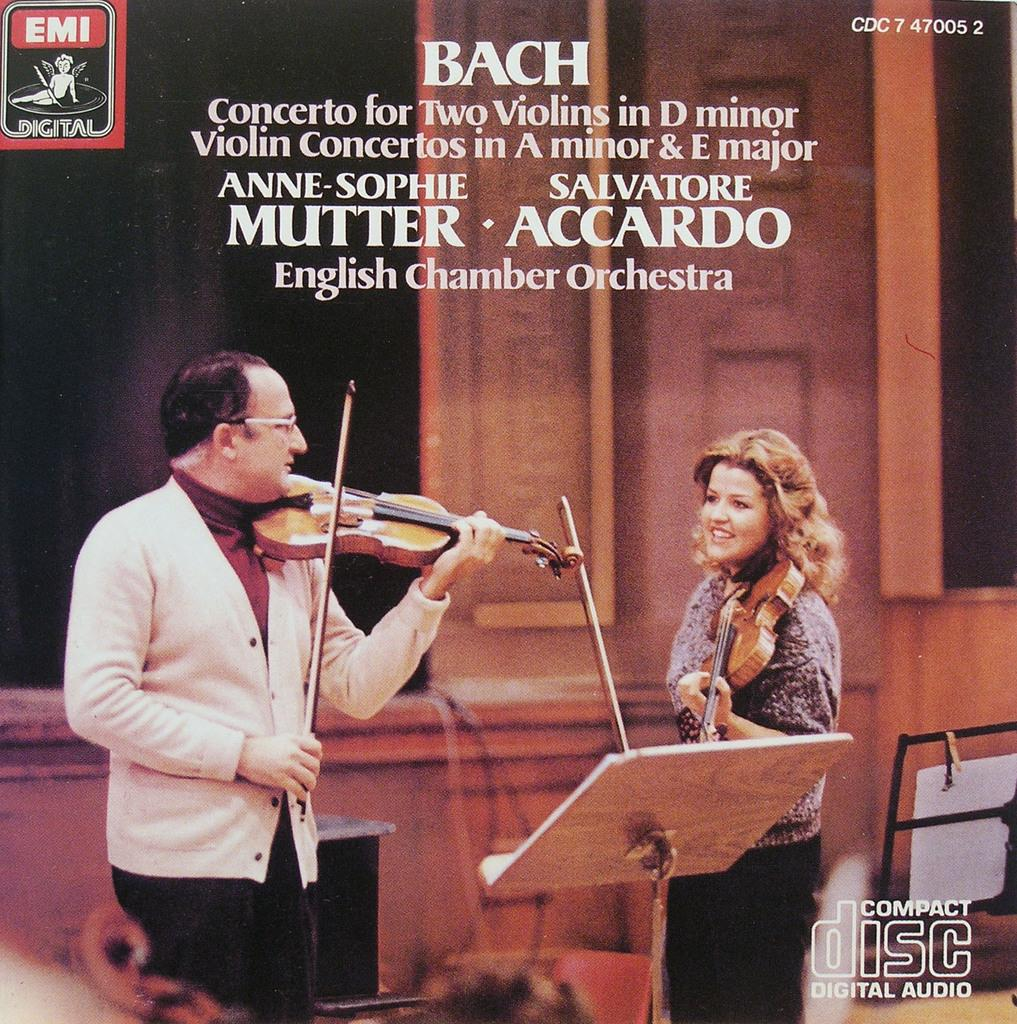How many people are in the image? There are two people in the image. What are the people doing in the image? The people are standing and playing violins. What is in front of the people? There is a table in front of the people. What is near the people? There is a wall near the people. Is there any text visible in the image? Yes, there is some text visible in the image. Can you tell me how many pens the servant is holding in the image? There is no servant present in the image, and no pens are visible. Can you describe the texture of the violin strings in the image? The image does not provide enough detail to describe the texture of the violin strings. 